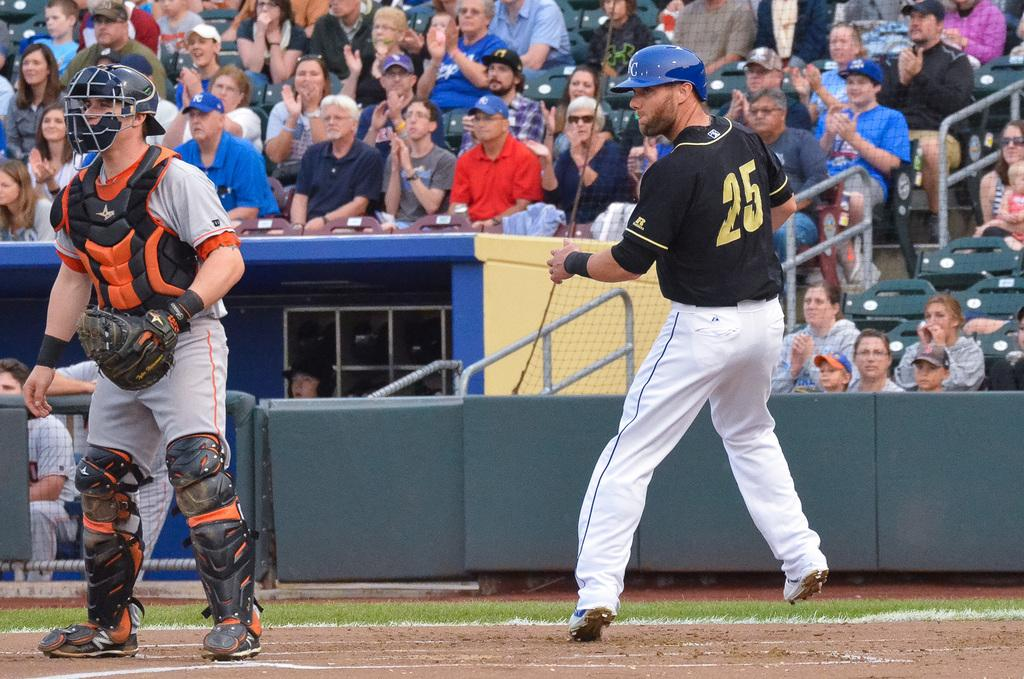<image>
Describe the image concisely. Player number  25 winding up to throw the ball. 